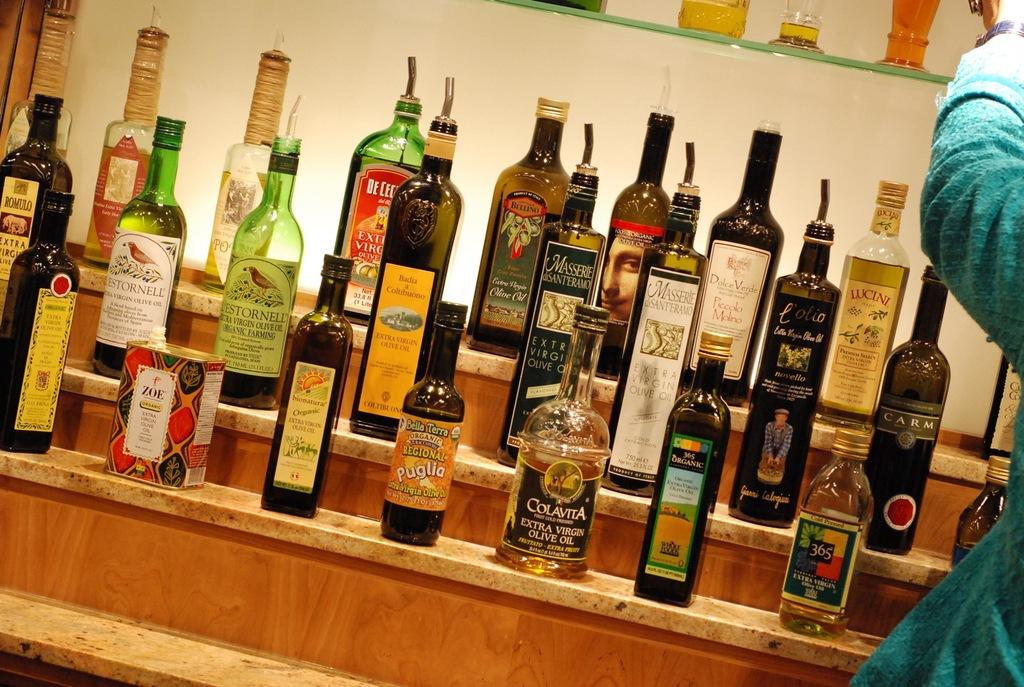<image>
Present a compact description of the photo's key features. the word colavita that is on an alcohol bottle 